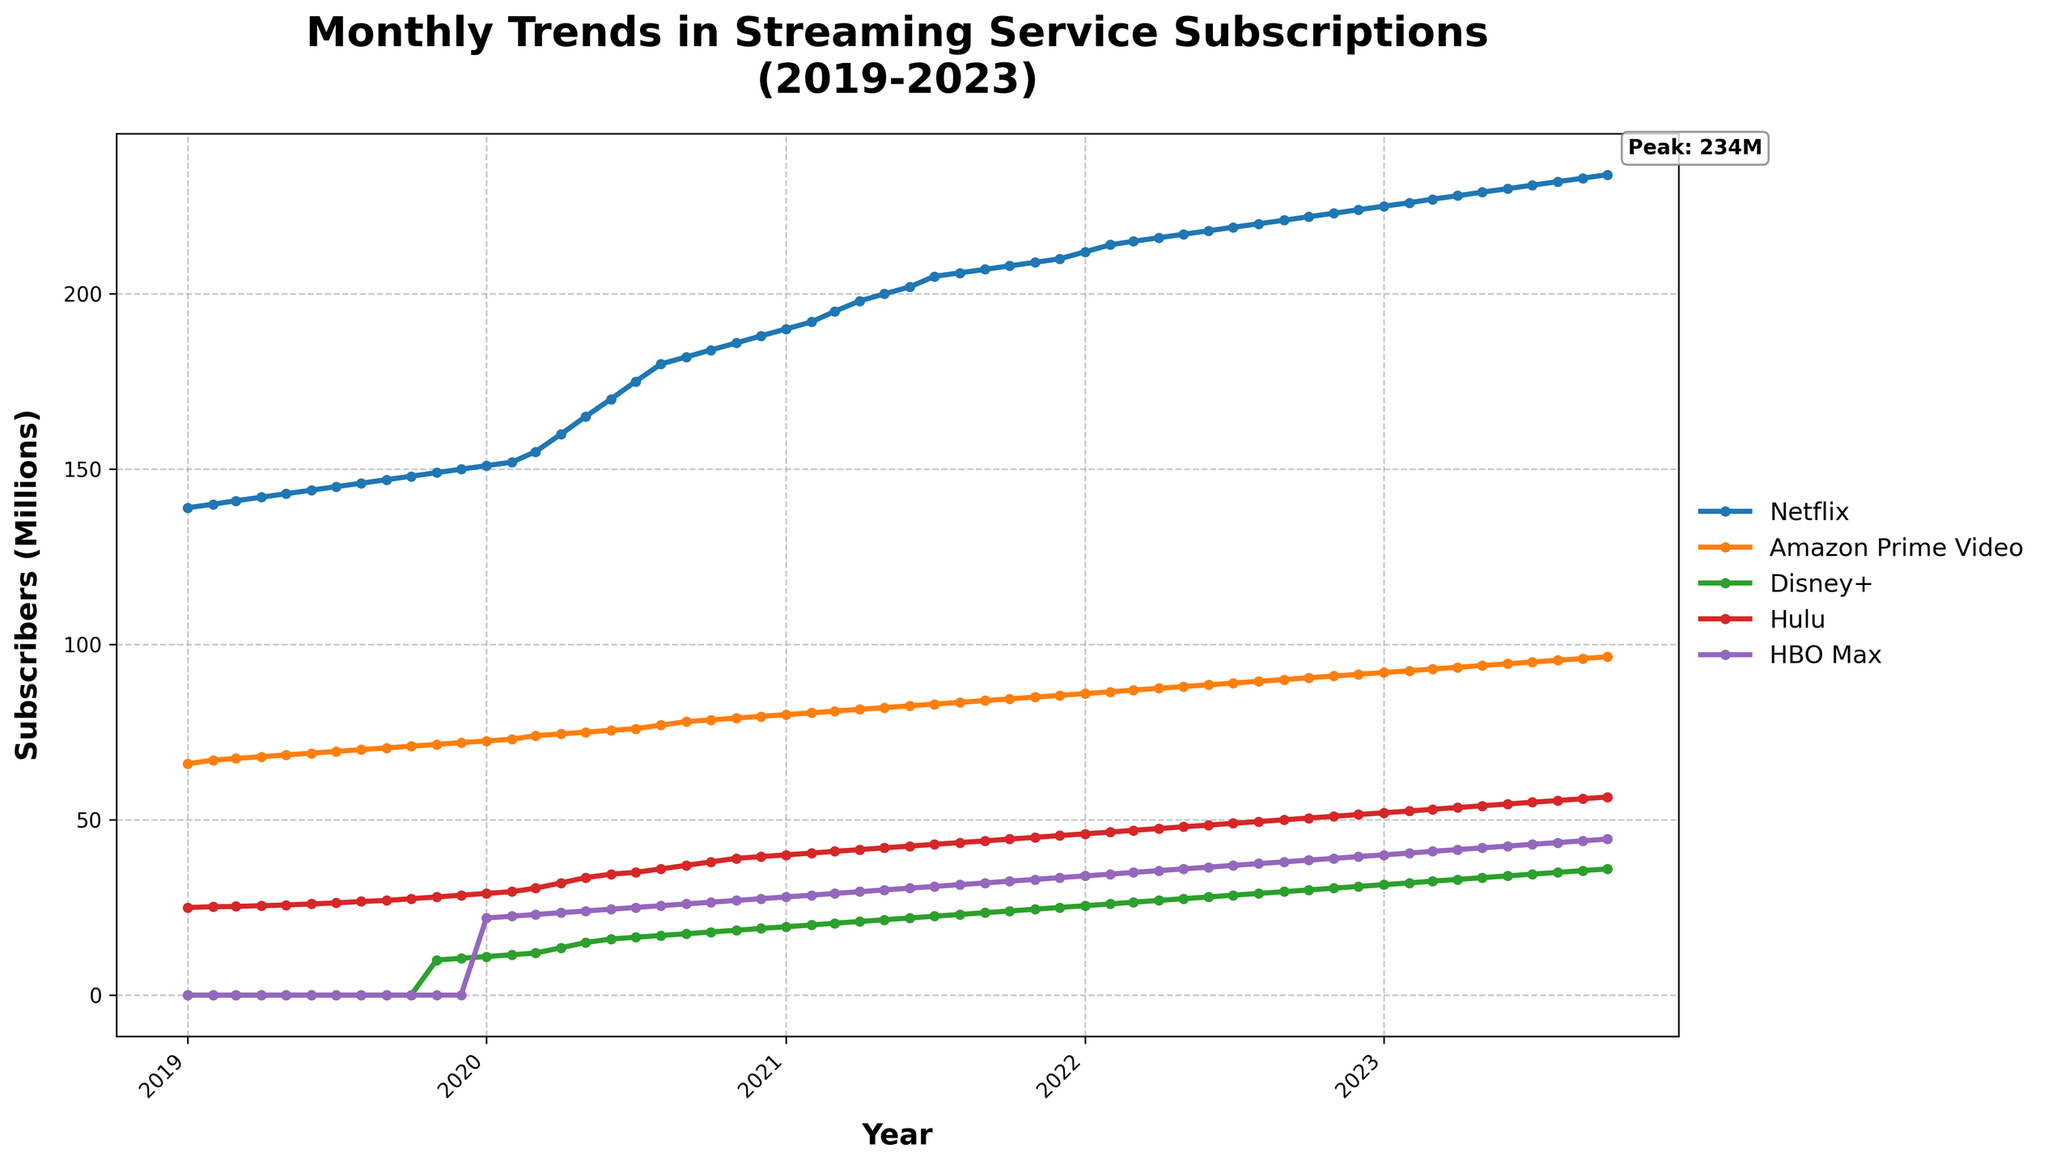What is the title of the figure? The title of the figure is written at the top. The figure's title is "Monthly Trends in Streaming Service Subscriptions (2019-2023)".
Answer: Monthly Trends in Streaming Service Subscriptions (2019-2023) How many streaming services are displayed in the plot? There are five streaming services displayed in the plot, indicated by the different colored lines and the legend on the right-hand side.
Answer: 5 Which streaming service had the highest number of subscribers at the end of the period? We need to look at the end of the time series (October 2023) and find the highest point among all lines. Netflix has the highest value at 234 million subscribers.
Answer: Netflix What was the trend of Disney+ subscriptions from its launch to October 2023? We need to follow the line representing Disney+ from its beginning in November 2019 until the end of the period. It started at 10 million subscribers and steadily increased to 36 million subscribers by October 2023.
Answer: Increasing trend Among the streaming services, which one had the most significant increase in subscribers from January 2020 to October 2023? We need to calculate the difference in subscribers for each service between January 2020 and October 2023. Netflix increased from 151 million to 234 million (83 million), Amazon Prime Video from 72.5 million to 96.5 million (24 million), Disney+ from 11 million to 36 million (25 million), Hulu from 29 million to 56.5 million (27.5 million), HBO Max from 22 million to 44.5 million (22.5 million). Netflix had the most significant increase.
Answer: Netflix How did the introduction of HBO Max impact the overall competition among the streaming services? HBO Max was introduced in January 2020. We need to observe if there’s any visible change in the slopes of the other streaming services’ lines around this period. The overall subscriber trends of Netflix, Amazon Prime Video, and Hulu don’t show a visible negative impact, as their trends continue to increase. HBO Max's introduction added competition but did not drastically change the trends of other services.
Answer: Increased competition without significant negative impact on others During which period did Netflix see the most significant growth in subscribers? By examining the slope of Netflix’s curve, the period with the steepest incline represents the most significant growth. The steepest increase appears to be from March 2020 to August 2020.
Answer: March 2020 to August 2020 Compare the subscription trends of Hulu and Amazon Prime Video. Which one grew faster over the five years? We need to compare the initial and final points of Hulu and Amazon Prime Video and find the growth rate. Hulu grew from 25 million to 56.5 million (31.5 million increase), and Amazon Prime Video grew from 66 million to 96.5 million (30.5 million increase). Hulu had a slightly faster growth rate over this period.
Answer: Hulu 